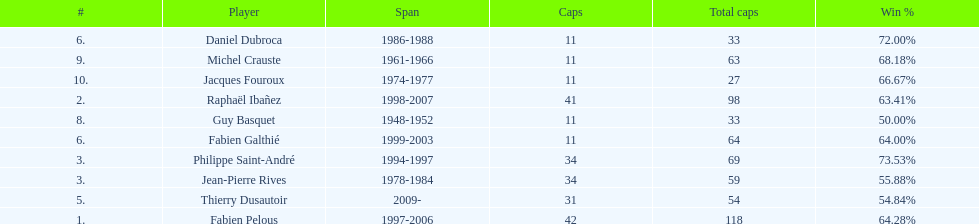How long did michel crauste serve as captain? 1961-1966. 